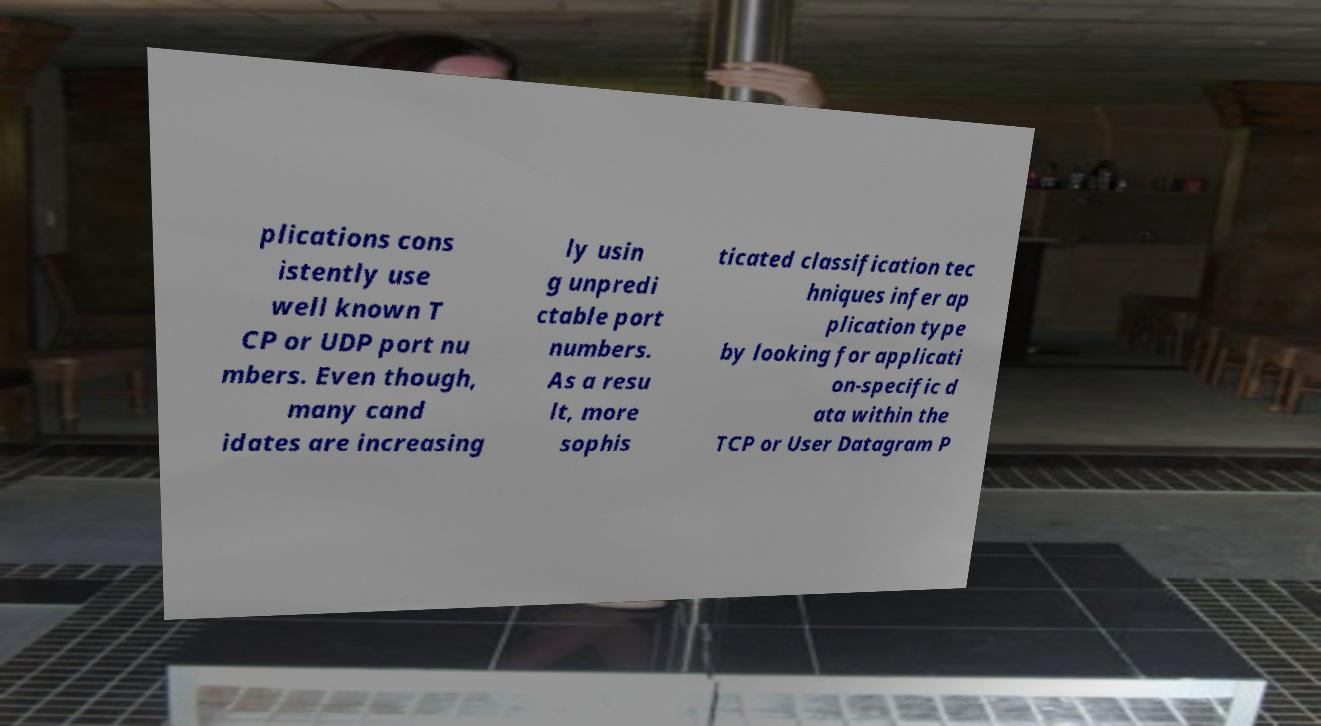Can you read and provide the text displayed in the image?This photo seems to have some interesting text. Can you extract and type it out for me? plications cons istently use well known T CP or UDP port nu mbers. Even though, many cand idates are increasing ly usin g unpredi ctable port numbers. As a resu lt, more sophis ticated classification tec hniques infer ap plication type by looking for applicati on-specific d ata within the TCP or User Datagram P 